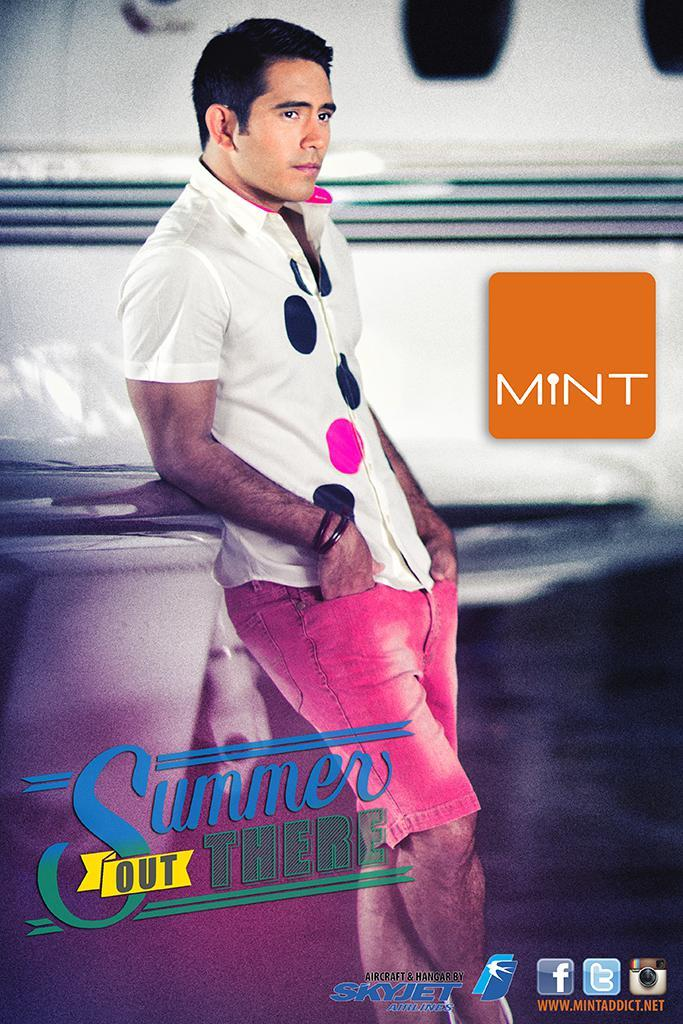What is the main subject of the image? There is a man standing in the image. What is the man wearing? The man is wearing a white shirt. What color is the background of the image? The background of the image is white. Can you describe any other objects in the image? There is an orange board in the image. Reasoning: Let' Let's think step by step in order to produce the conversation. We start by identifying the main subject of the image, which is the man standing. Then, we describe what the man is wearing, which is a white shirt. Next, we mention the color of the background, which is white. Finally, we identify any other objects in the image, which is the orange board. Absurd Question/Answer: What type of sweater is the man's grandfather wearing in the image? There is no grandfather or sweater present in the image. What type of oatmeal is being served on the orange board in the image? There is no oatmeal or serving in the image; it only features a man standing and an orange board. 